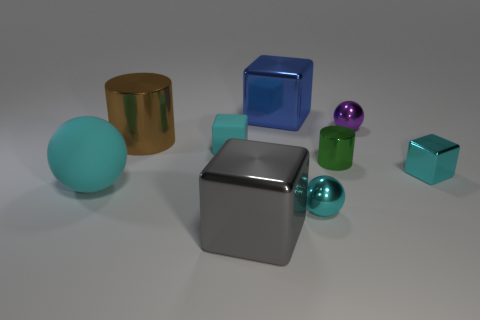What material is the ball left of the blue block that is behind the tiny metal ball behind the green cylinder?
Make the answer very short. Rubber. How many things are either metallic things that are on the right side of the blue shiny object or tiny purple balls?
Your answer should be compact. 4. What number of other objects are there of the same shape as the tiny matte thing?
Your response must be concise. 3. Is the number of purple shiny spheres in front of the large brown metal cylinder greater than the number of big matte objects?
Give a very brief answer. No. There is a blue metal object that is the same shape as the big gray metal thing; what is its size?
Your response must be concise. Large. Is there any other thing that is made of the same material as the tiny green thing?
Keep it short and to the point. Yes. What is the shape of the large gray metallic thing?
Provide a succinct answer. Cube. There is a rubber thing that is the same size as the gray cube; what shape is it?
Your answer should be compact. Sphere. Are there any other things of the same color as the big matte object?
Make the answer very short. Yes. What size is the object that is the same material as the big cyan ball?
Provide a succinct answer. Small. 